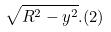<formula> <loc_0><loc_0><loc_500><loc_500>\sqrt { R ^ { 2 } - y ^ { 2 } } . ( 2 )</formula> 